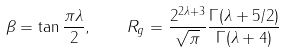Convert formula to latex. <formula><loc_0><loc_0><loc_500><loc_500>\beta = \tan \frac { \pi \lambda } { 2 } , \quad R _ { g } = \frac { 2 ^ { 2 \lambda + 3 } } { \sqrt { \pi } } \frac { \Gamma ( \lambda + 5 / 2 ) } { \Gamma ( \lambda + 4 ) }</formula> 